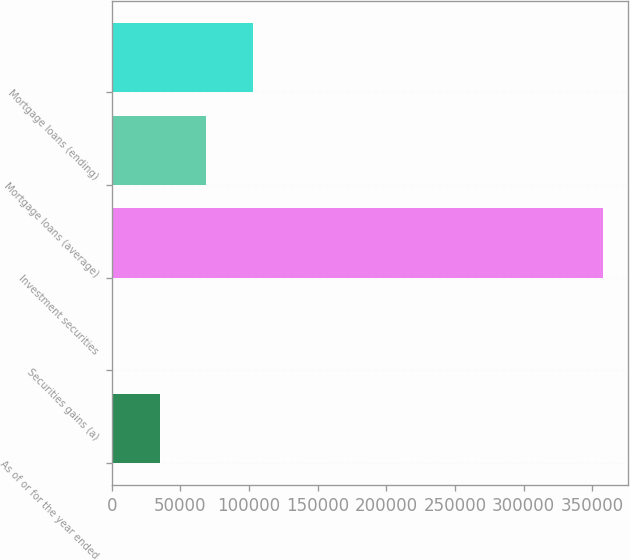Convert chart. <chart><loc_0><loc_0><loc_500><loc_500><bar_chart><fcel>As of or for the year ended<fcel>Securities gains (a)<fcel>Investment securities<fcel>Mortgage loans (average)<fcel>Mortgage loans (ending)<nl><fcel>35048.6<fcel>1147<fcel>357939<fcel>68950.2<fcel>102852<nl></chart> 